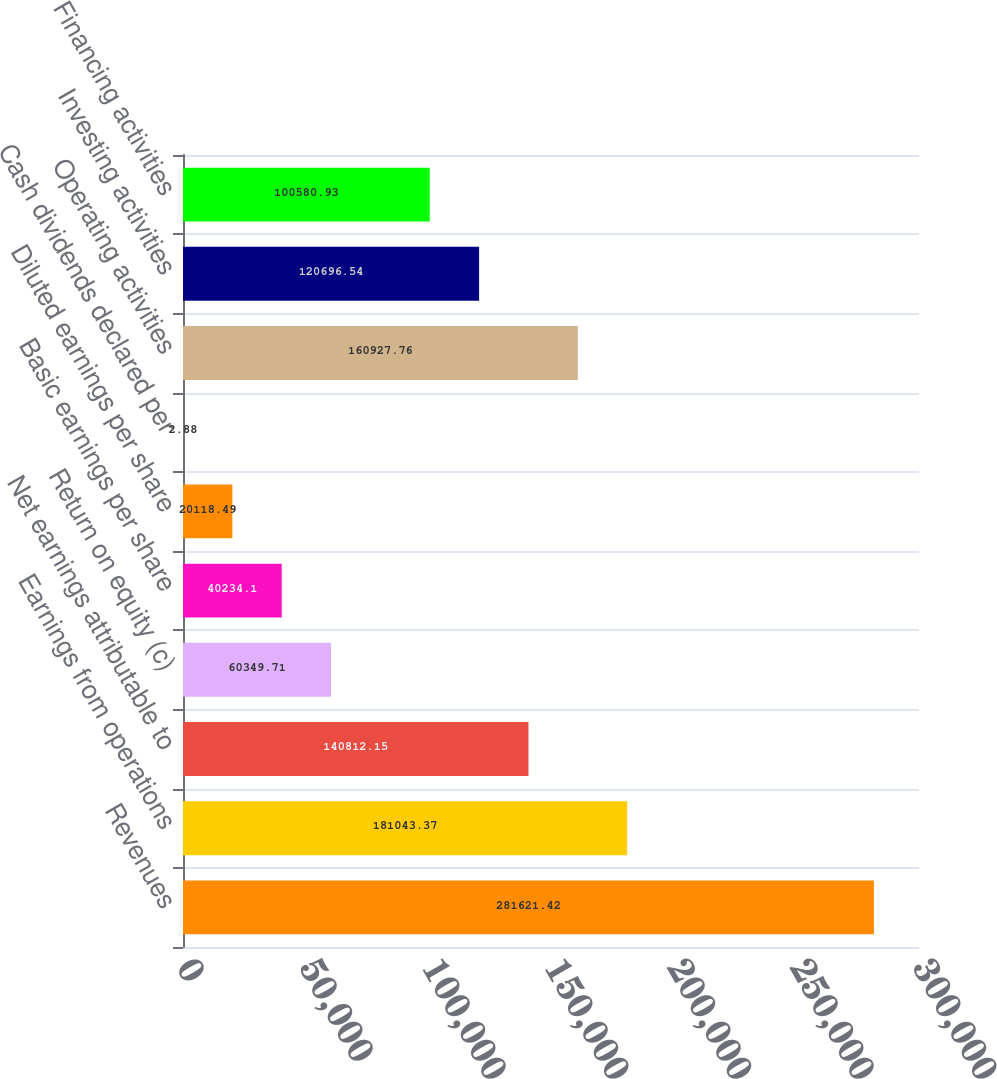Convert chart to OTSL. <chart><loc_0><loc_0><loc_500><loc_500><bar_chart><fcel>Revenues<fcel>Earnings from operations<fcel>Net earnings attributable to<fcel>Return on equity (c)<fcel>Basic earnings per share<fcel>Diluted earnings per share<fcel>Cash dividends declared per<fcel>Operating activities<fcel>Investing activities<fcel>Financing activities<nl><fcel>281621<fcel>181043<fcel>140812<fcel>60349.7<fcel>40234.1<fcel>20118.5<fcel>2.88<fcel>160928<fcel>120697<fcel>100581<nl></chart> 